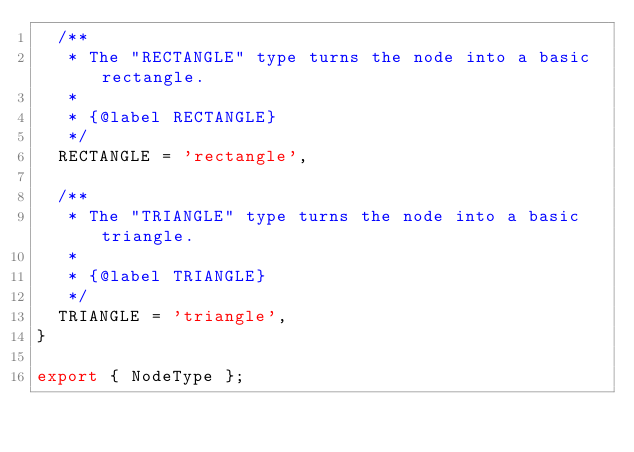<code> <loc_0><loc_0><loc_500><loc_500><_TypeScript_>  /**
   * The "RECTANGLE" type turns the node into a basic rectangle.
   *
   * {@label RECTANGLE}
   */
  RECTANGLE = 'rectangle',

  /**
   * The "TRIANGLE" type turns the node into a basic triangle.
   *
   * {@label TRIANGLE}
   */
  TRIANGLE = 'triangle',
}

export { NodeType };
</code> 